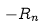<formula> <loc_0><loc_0><loc_500><loc_500>- R _ { n }</formula> 